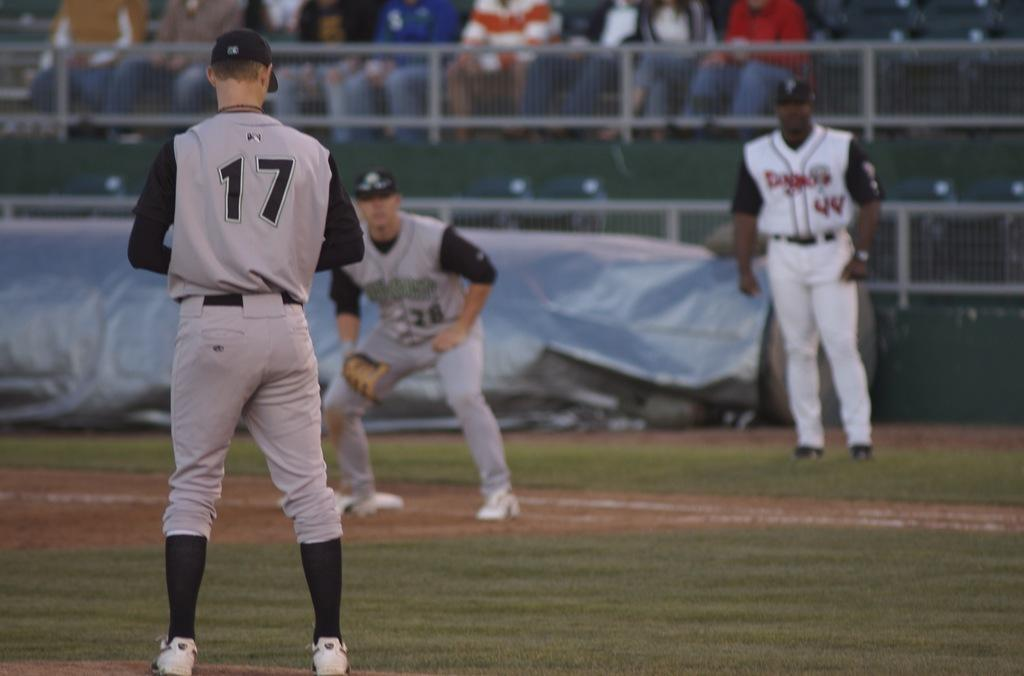<image>
Describe the image concisely. Number 17 is on the mound and his first baseman is watching him. 